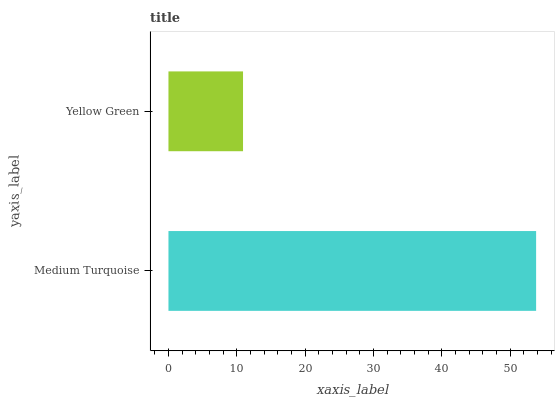Is Yellow Green the minimum?
Answer yes or no. Yes. Is Medium Turquoise the maximum?
Answer yes or no. Yes. Is Yellow Green the maximum?
Answer yes or no. No. Is Medium Turquoise greater than Yellow Green?
Answer yes or no. Yes. Is Yellow Green less than Medium Turquoise?
Answer yes or no. Yes. Is Yellow Green greater than Medium Turquoise?
Answer yes or no. No. Is Medium Turquoise less than Yellow Green?
Answer yes or no. No. Is Medium Turquoise the high median?
Answer yes or no. Yes. Is Yellow Green the low median?
Answer yes or no. Yes. Is Yellow Green the high median?
Answer yes or no. No. Is Medium Turquoise the low median?
Answer yes or no. No. 